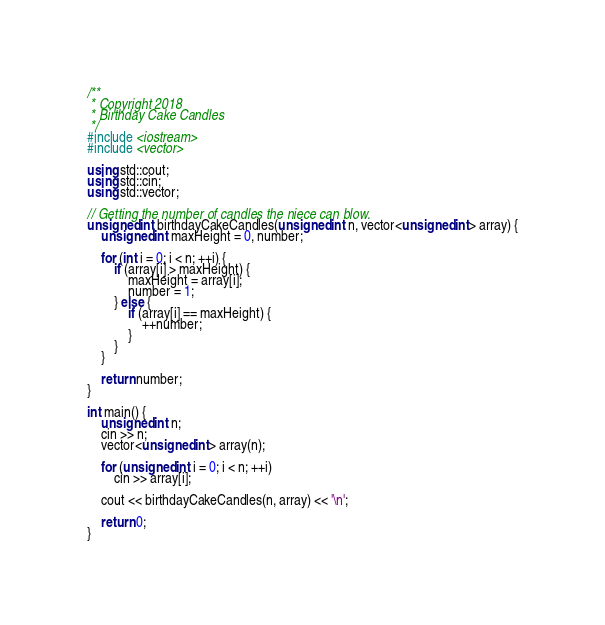<code> <loc_0><loc_0><loc_500><loc_500><_C++_>/**
 * Copyright 2018
 * Birthday Cake Candles
 */
#include <iostream>
#include <vector>

using std::cout;
using std::cin;
using std::vector;

// Getting the number of candles the niece can blow.
unsigned int birthdayCakeCandles(unsigned int n, vector<unsigned int> array) {
    unsigned int maxHeight = 0, number;
    
    for (int i = 0; i < n; ++i) {
        if (array[i] > maxHeight) {
            maxHeight = array[i];
            number = 1;
        } else {
            if (array[i] == maxHeight) {
                ++number;
            }
        }
    }
    
    return number;
}

int main() {
    unsigned int n;
    cin >> n;
    vector<unsigned int> array(n);

    for (unsigned int i = 0; i < n; ++i)
        cin >> array[i];

    cout << birthdayCakeCandles(n, array) << '\n';
    
    return 0;
}
</code> 